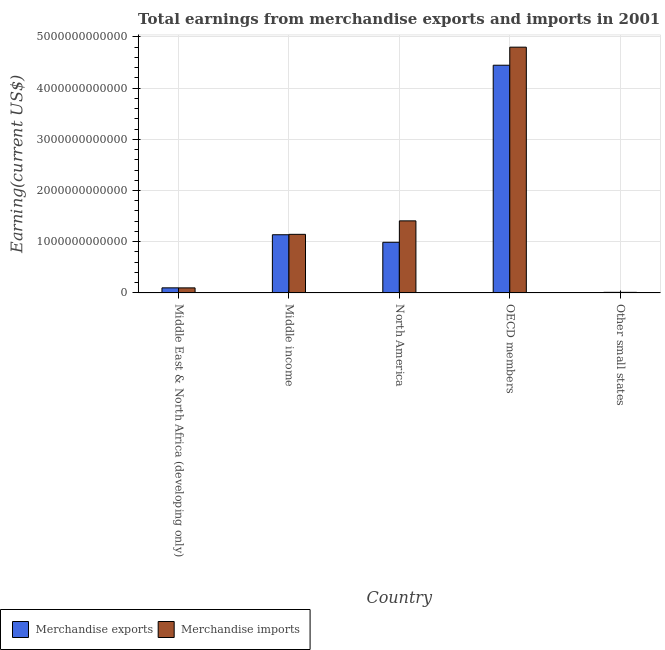How many different coloured bars are there?
Your answer should be very brief. 2. How many groups of bars are there?
Make the answer very short. 5. Are the number of bars on each tick of the X-axis equal?
Your answer should be compact. Yes. How many bars are there on the 3rd tick from the right?
Offer a very short reply. 2. What is the label of the 1st group of bars from the left?
Your answer should be very brief. Middle East & North Africa (developing only). What is the earnings from merchandise imports in OECD members?
Keep it short and to the point. 4.80e+12. Across all countries, what is the maximum earnings from merchandise exports?
Keep it short and to the point. 4.45e+12. Across all countries, what is the minimum earnings from merchandise imports?
Your answer should be compact. 1.16e+1. In which country was the earnings from merchandise exports maximum?
Provide a short and direct response. OECD members. In which country was the earnings from merchandise imports minimum?
Ensure brevity in your answer.  Other small states. What is the total earnings from merchandise imports in the graph?
Your response must be concise. 7.46e+12. What is the difference between the earnings from merchandise exports in North America and that in OECD members?
Your answer should be very brief. -3.46e+12. What is the difference between the earnings from merchandise imports in OECD members and the earnings from merchandise exports in Other small states?
Offer a terse response. 4.79e+12. What is the average earnings from merchandise exports per country?
Ensure brevity in your answer.  1.34e+12. What is the difference between the earnings from merchandise exports and earnings from merchandise imports in Middle income?
Your answer should be compact. -8.05e+09. What is the ratio of the earnings from merchandise imports in Middle income to that in OECD members?
Make the answer very short. 0.24. Is the earnings from merchandise exports in Middle income less than that in North America?
Offer a very short reply. No. Is the difference between the earnings from merchandise exports in North America and OECD members greater than the difference between the earnings from merchandise imports in North America and OECD members?
Ensure brevity in your answer.  No. What is the difference between the highest and the second highest earnings from merchandise exports?
Provide a succinct answer. 3.31e+12. What is the difference between the highest and the lowest earnings from merchandise exports?
Keep it short and to the point. 4.43e+12. What does the 1st bar from the left in OECD members represents?
Provide a short and direct response. Merchandise exports. What does the 2nd bar from the right in OECD members represents?
Provide a short and direct response. Merchandise exports. How many bars are there?
Your answer should be compact. 10. Are all the bars in the graph horizontal?
Offer a very short reply. No. How many countries are there in the graph?
Provide a succinct answer. 5. What is the difference between two consecutive major ticks on the Y-axis?
Your response must be concise. 1.00e+12. Where does the legend appear in the graph?
Make the answer very short. Bottom left. How many legend labels are there?
Make the answer very short. 2. How are the legend labels stacked?
Your answer should be compact. Horizontal. What is the title of the graph?
Provide a succinct answer. Total earnings from merchandise exports and imports in 2001. Does "ODA received" appear as one of the legend labels in the graph?
Your answer should be compact. No. What is the label or title of the Y-axis?
Give a very brief answer. Earning(current US$). What is the Earning(current US$) in Merchandise exports in Middle East & North Africa (developing only)?
Give a very brief answer. 9.95e+1. What is the Earning(current US$) in Merchandise imports in Middle East & North Africa (developing only)?
Make the answer very short. 9.88e+1. What is the Earning(current US$) of Merchandise exports in Middle income?
Your answer should be very brief. 1.14e+12. What is the Earning(current US$) in Merchandise imports in Middle income?
Make the answer very short. 1.14e+12. What is the Earning(current US$) in Merchandise exports in North America?
Offer a terse response. 9.89e+11. What is the Earning(current US$) of Merchandise imports in North America?
Your answer should be compact. 1.41e+12. What is the Earning(current US$) in Merchandise exports in OECD members?
Ensure brevity in your answer.  4.45e+12. What is the Earning(current US$) in Merchandise imports in OECD members?
Your answer should be compact. 4.80e+12. What is the Earning(current US$) of Merchandise exports in Other small states?
Provide a succinct answer. 1.18e+1. What is the Earning(current US$) of Merchandise imports in Other small states?
Your response must be concise. 1.16e+1. Across all countries, what is the maximum Earning(current US$) of Merchandise exports?
Offer a very short reply. 4.45e+12. Across all countries, what is the maximum Earning(current US$) of Merchandise imports?
Make the answer very short. 4.80e+12. Across all countries, what is the minimum Earning(current US$) in Merchandise exports?
Offer a very short reply. 1.18e+1. Across all countries, what is the minimum Earning(current US$) of Merchandise imports?
Make the answer very short. 1.16e+1. What is the total Earning(current US$) in Merchandise exports in the graph?
Ensure brevity in your answer.  6.68e+12. What is the total Earning(current US$) of Merchandise imports in the graph?
Make the answer very short. 7.46e+12. What is the difference between the Earning(current US$) of Merchandise exports in Middle East & North Africa (developing only) and that in Middle income?
Provide a short and direct response. -1.04e+12. What is the difference between the Earning(current US$) of Merchandise imports in Middle East & North Africa (developing only) and that in Middle income?
Give a very brief answer. -1.05e+12. What is the difference between the Earning(current US$) in Merchandise exports in Middle East & North Africa (developing only) and that in North America?
Offer a terse response. -8.90e+11. What is the difference between the Earning(current US$) of Merchandise imports in Middle East & North Africa (developing only) and that in North America?
Offer a very short reply. -1.31e+12. What is the difference between the Earning(current US$) of Merchandise exports in Middle East & North Africa (developing only) and that in OECD members?
Make the answer very short. -4.35e+12. What is the difference between the Earning(current US$) in Merchandise imports in Middle East & North Africa (developing only) and that in OECD members?
Keep it short and to the point. -4.70e+12. What is the difference between the Earning(current US$) of Merchandise exports in Middle East & North Africa (developing only) and that in Other small states?
Offer a very short reply. 8.77e+1. What is the difference between the Earning(current US$) of Merchandise imports in Middle East & North Africa (developing only) and that in Other small states?
Ensure brevity in your answer.  8.73e+1. What is the difference between the Earning(current US$) of Merchandise exports in Middle income and that in North America?
Provide a short and direct response. 1.47e+11. What is the difference between the Earning(current US$) in Merchandise imports in Middle income and that in North America?
Provide a succinct answer. -2.63e+11. What is the difference between the Earning(current US$) in Merchandise exports in Middle income and that in OECD members?
Your answer should be very brief. -3.31e+12. What is the difference between the Earning(current US$) of Merchandise imports in Middle income and that in OECD members?
Ensure brevity in your answer.  -3.65e+12. What is the difference between the Earning(current US$) in Merchandise exports in Middle income and that in Other small states?
Make the answer very short. 1.12e+12. What is the difference between the Earning(current US$) of Merchandise imports in Middle income and that in Other small states?
Ensure brevity in your answer.  1.13e+12. What is the difference between the Earning(current US$) in Merchandise exports in North America and that in OECD members?
Your response must be concise. -3.46e+12. What is the difference between the Earning(current US$) in Merchandise imports in North America and that in OECD members?
Ensure brevity in your answer.  -3.39e+12. What is the difference between the Earning(current US$) of Merchandise exports in North America and that in Other small states?
Give a very brief answer. 9.77e+11. What is the difference between the Earning(current US$) of Merchandise imports in North America and that in Other small states?
Offer a terse response. 1.40e+12. What is the difference between the Earning(current US$) of Merchandise exports in OECD members and that in Other small states?
Give a very brief answer. 4.43e+12. What is the difference between the Earning(current US$) in Merchandise imports in OECD members and that in Other small states?
Keep it short and to the point. 4.79e+12. What is the difference between the Earning(current US$) of Merchandise exports in Middle East & North Africa (developing only) and the Earning(current US$) of Merchandise imports in Middle income?
Provide a short and direct response. -1.04e+12. What is the difference between the Earning(current US$) of Merchandise exports in Middle East & North Africa (developing only) and the Earning(current US$) of Merchandise imports in North America?
Give a very brief answer. -1.31e+12. What is the difference between the Earning(current US$) of Merchandise exports in Middle East & North Africa (developing only) and the Earning(current US$) of Merchandise imports in OECD members?
Give a very brief answer. -4.70e+12. What is the difference between the Earning(current US$) in Merchandise exports in Middle East & North Africa (developing only) and the Earning(current US$) in Merchandise imports in Other small states?
Make the answer very short. 8.79e+1. What is the difference between the Earning(current US$) in Merchandise exports in Middle income and the Earning(current US$) in Merchandise imports in North America?
Provide a succinct answer. -2.71e+11. What is the difference between the Earning(current US$) of Merchandise exports in Middle income and the Earning(current US$) of Merchandise imports in OECD members?
Your response must be concise. -3.66e+12. What is the difference between the Earning(current US$) in Merchandise exports in Middle income and the Earning(current US$) in Merchandise imports in Other small states?
Your response must be concise. 1.12e+12. What is the difference between the Earning(current US$) in Merchandise exports in North America and the Earning(current US$) in Merchandise imports in OECD members?
Provide a short and direct response. -3.81e+12. What is the difference between the Earning(current US$) in Merchandise exports in North America and the Earning(current US$) in Merchandise imports in Other small states?
Ensure brevity in your answer.  9.77e+11. What is the difference between the Earning(current US$) in Merchandise exports in OECD members and the Earning(current US$) in Merchandise imports in Other small states?
Your response must be concise. 4.43e+12. What is the average Earning(current US$) in Merchandise exports per country?
Keep it short and to the point. 1.34e+12. What is the average Earning(current US$) of Merchandise imports per country?
Ensure brevity in your answer.  1.49e+12. What is the difference between the Earning(current US$) in Merchandise exports and Earning(current US$) in Merchandise imports in Middle East & North Africa (developing only)?
Your answer should be compact. 6.45e+08. What is the difference between the Earning(current US$) of Merchandise exports and Earning(current US$) of Merchandise imports in Middle income?
Your answer should be compact. -8.05e+09. What is the difference between the Earning(current US$) of Merchandise exports and Earning(current US$) of Merchandise imports in North America?
Your answer should be compact. -4.18e+11. What is the difference between the Earning(current US$) in Merchandise exports and Earning(current US$) in Merchandise imports in OECD members?
Your answer should be compact. -3.53e+11. What is the difference between the Earning(current US$) of Merchandise exports and Earning(current US$) of Merchandise imports in Other small states?
Offer a terse response. 2.31e+08. What is the ratio of the Earning(current US$) in Merchandise exports in Middle East & North Africa (developing only) to that in Middle income?
Offer a very short reply. 0.09. What is the ratio of the Earning(current US$) of Merchandise imports in Middle East & North Africa (developing only) to that in Middle income?
Make the answer very short. 0.09. What is the ratio of the Earning(current US$) in Merchandise exports in Middle East & North Africa (developing only) to that in North America?
Ensure brevity in your answer.  0.1. What is the ratio of the Earning(current US$) of Merchandise imports in Middle East & North Africa (developing only) to that in North America?
Offer a terse response. 0.07. What is the ratio of the Earning(current US$) of Merchandise exports in Middle East & North Africa (developing only) to that in OECD members?
Ensure brevity in your answer.  0.02. What is the ratio of the Earning(current US$) of Merchandise imports in Middle East & North Africa (developing only) to that in OECD members?
Make the answer very short. 0.02. What is the ratio of the Earning(current US$) of Merchandise exports in Middle East & North Africa (developing only) to that in Other small states?
Offer a very short reply. 8.42. What is the ratio of the Earning(current US$) of Merchandise imports in Middle East & North Africa (developing only) to that in Other small states?
Provide a short and direct response. 8.53. What is the ratio of the Earning(current US$) of Merchandise exports in Middle income to that in North America?
Ensure brevity in your answer.  1.15. What is the ratio of the Earning(current US$) in Merchandise imports in Middle income to that in North America?
Make the answer very short. 0.81. What is the ratio of the Earning(current US$) of Merchandise exports in Middle income to that in OECD members?
Provide a short and direct response. 0.26. What is the ratio of the Earning(current US$) of Merchandise imports in Middle income to that in OECD members?
Your answer should be very brief. 0.24. What is the ratio of the Earning(current US$) of Merchandise exports in Middle income to that in Other small states?
Offer a terse response. 96.13. What is the ratio of the Earning(current US$) of Merchandise imports in Middle income to that in Other small states?
Give a very brief answer. 98.75. What is the ratio of the Earning(current US$) in Merchandise exports in North America to that in OECD members?
Give a very brief answer. 0.22. What is the ratio of the Earning(current US$) in Merchandise imports in North America to that in OECD members?
Offer a very short reply. 0.29. What is the ratio of the Earning(current US$) in Merchandise exports in North America to that in Other small states?
Offer a very short reply. 83.67. What is the ratio of the Earning(current US$) of Merchandise imports in North America to that in Other small states?
Your answer should be compact. 121.43. What is the ratio of the Earning(current US$) in Merchandise exports in OECD members to that in Other small states?
Offer a very short reply. 376.14. What is the ratio of the Earning(current US$) of Merchandise imports in OECD members to that in Other small states?
Give a very brief answer. 414.09. What is the difference between the highest and the second highest Earning(current US$) in Merchandise exports?
Your answer should be very brief. 3.31e+12. What is the difference between the highest and the second highest Earning(current US$) in Merchandise imports?
Your answer should be very brief. 3.39e+12. What is the difference between the highest and the lowest Earning(current US$) in Merchandise exports?
Give a very brief answer. 4.43e+12. What is the difference between the highest and the lowest Earning(current US$) of Merchandise imports?
Your answer should be compact. 4.79e+12. 